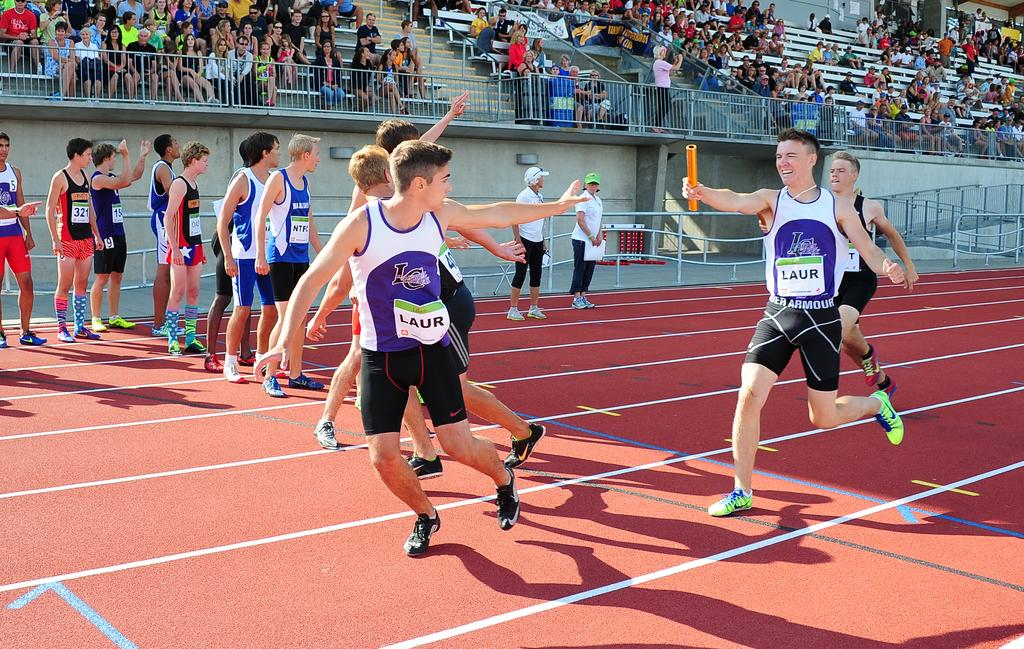<image>
Write a terse but informative summary of the picture. A young male wearing Under Armour shorts holds an orange baton. 